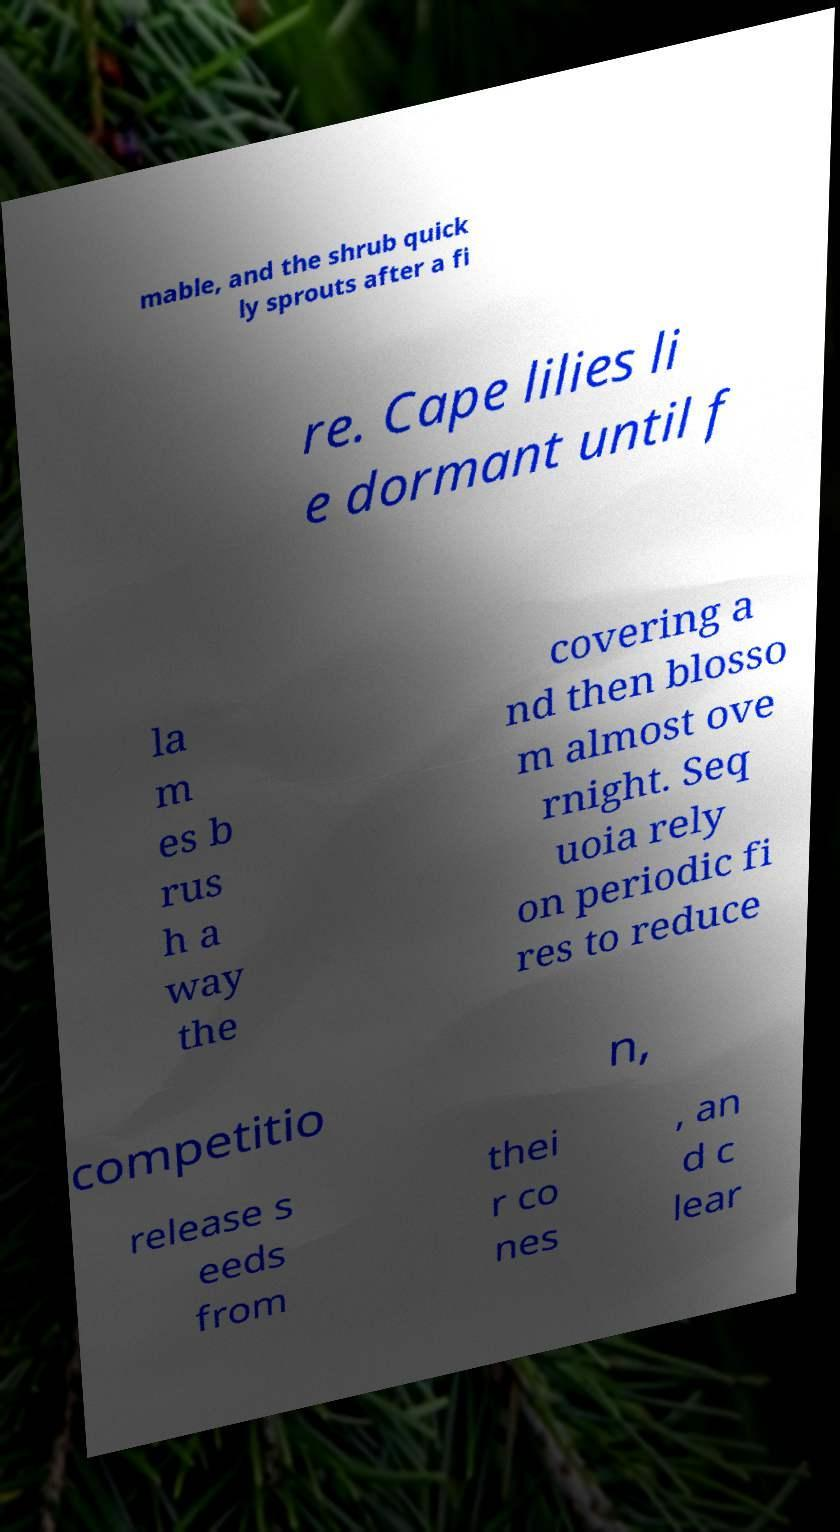Could you assist in decoding the text presented in this image and type it out clearly? mable, and the shrub quick ly sprouts after a fi re. Cape lilies li e dormant until f la m es b rus h a way the covering a nd then blosso m almost ove rnight. Seq uoia rely on periodic fi res to reduce competitio n, release s eeds from thei r co nes , an d c lear 